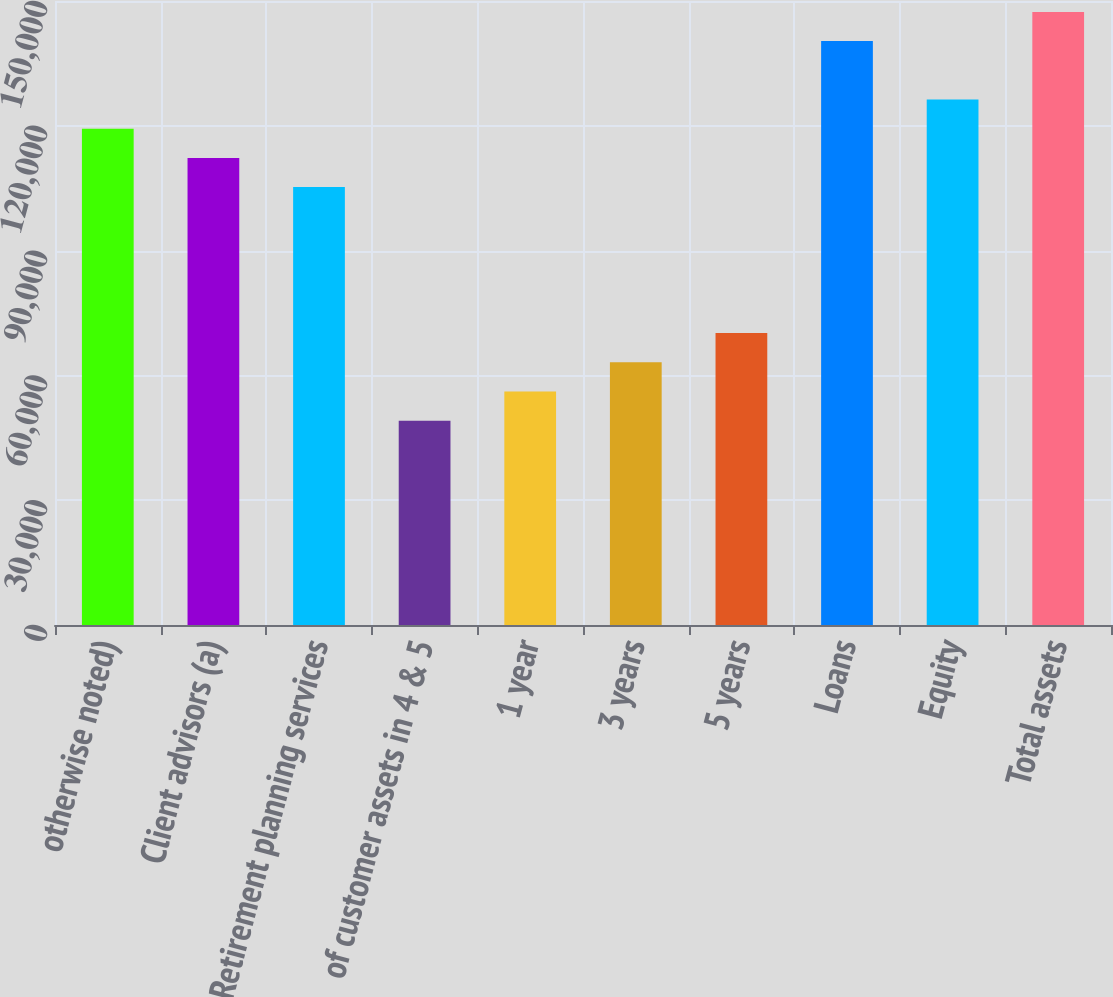<chart> <loc_0><loc_0><loc_500><loc_500><bar_chart><fcel>otherwise noted)<fcel>Client advisors (a)<fcel>Retirement planning services<fcel>of customer assets in 4 & 5<fcel>1 year<fcel>3 years<fcel>5 years<fcel>Loans<fcel>Equity<fcel>Total assets<nl><fcel>119304<fcel>112286<fcel>105269<fcel>49125.3<fcel>56143.2<fcel>63161.1<fcel>70179<fcel>140358<fcel>126322<fcel>147376<nl></chart> 